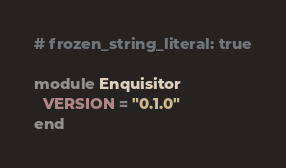<code> <loc_0><loc_0><loc_500><loc_500><_Ruby_># frozen_string_literal: true

module Enquisitor
  VERSION = "0.1.0"
end
</code> 